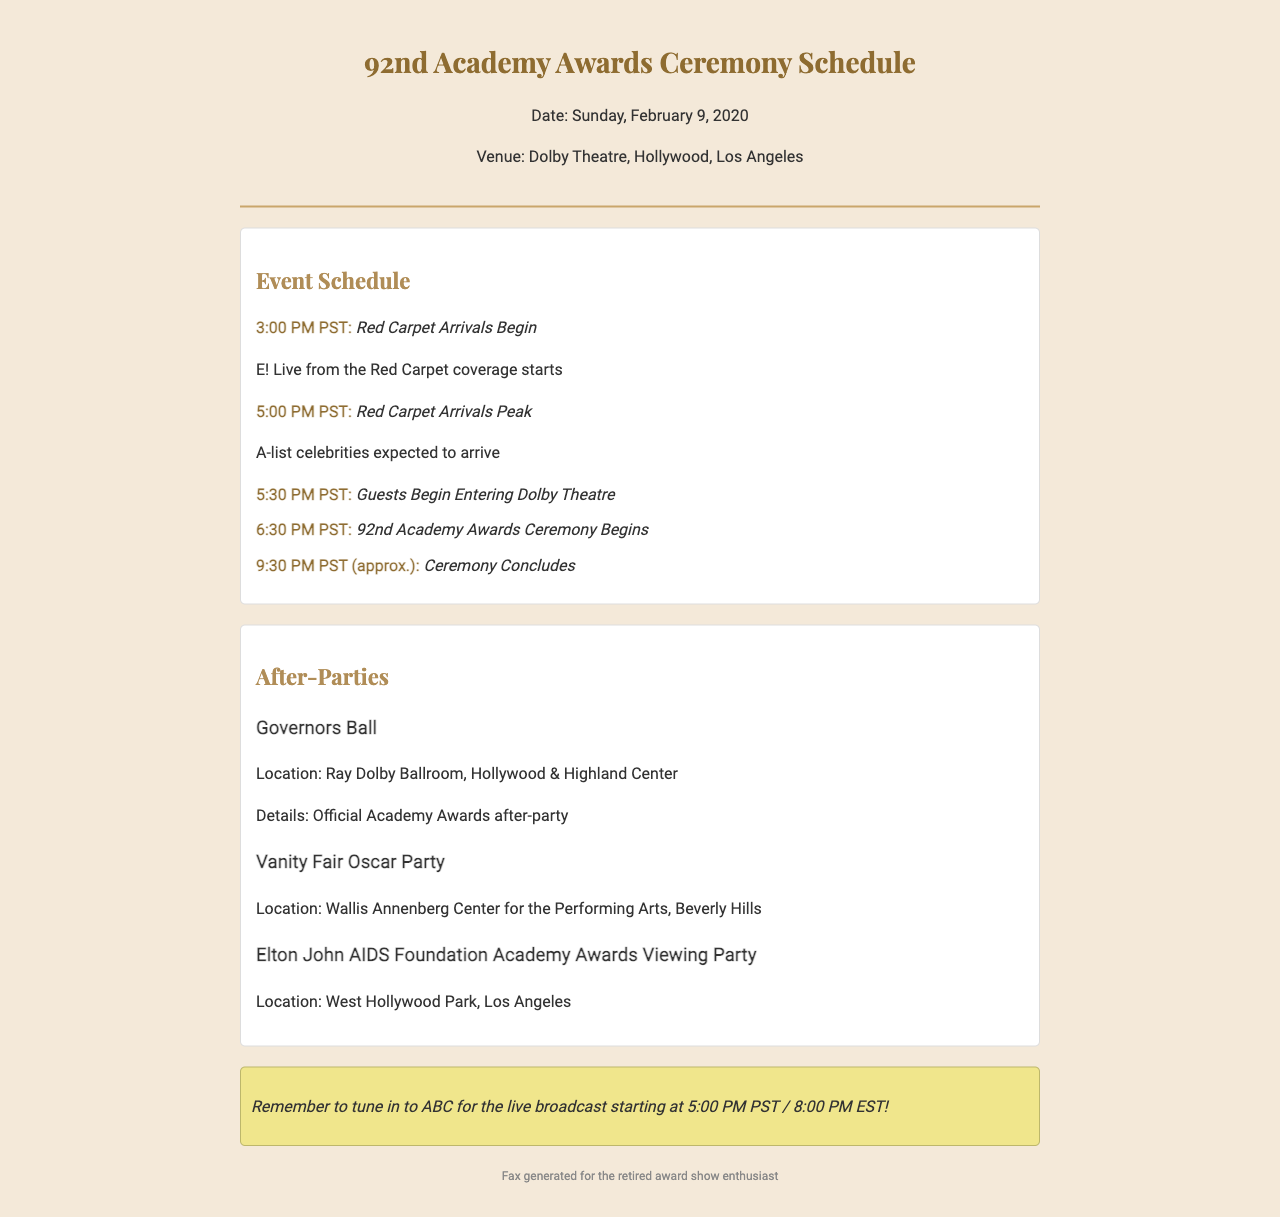What time do the red carpet arrivals begin? The document states that red carpet arrivals begin at 3:00 PM PST.
Answer: 3:00 PM PST What is the location of the Governors Ball? The document specifies that the Governors Ball is located at Ray Dolby Ballroom, Hollywood & Highland Center.
Answer: Ray Dolby Ballroom, Hollywood & Highland Center When does the 92nd Academy Awards Ceremony begin? According to the schedule, the ceremony begins at 6:30 PM PST.
Answer: 6:30 PM PST What is the title of the after-party hosted by Vanity Fair? The document lists the after-party hosted by Vanity Fair as the Vanity Fair Oscar Party.
Answer: Vanity Fair Oscar Party Approximately what time does the ceremony conclude? The document mentions that the ceremony concludes around 9:30 PM PST.
Answer: 9:30 PM PST Which network is broadcasting the awards ceremony live? The document instructs to tune in to ABC for the live broadcast.
Answer: ABC What is the theme of the note at the bottom of the fax? The note reminds readers to watch the live broadcast of the ceremony starting at 5:00 PM PST.
Answer: Tune in to ABC for the live broadcast What type of event is the document related to? The document outlines the schedule for the Academy Awards ceremony.
Answer: Academy Awards ceremony 